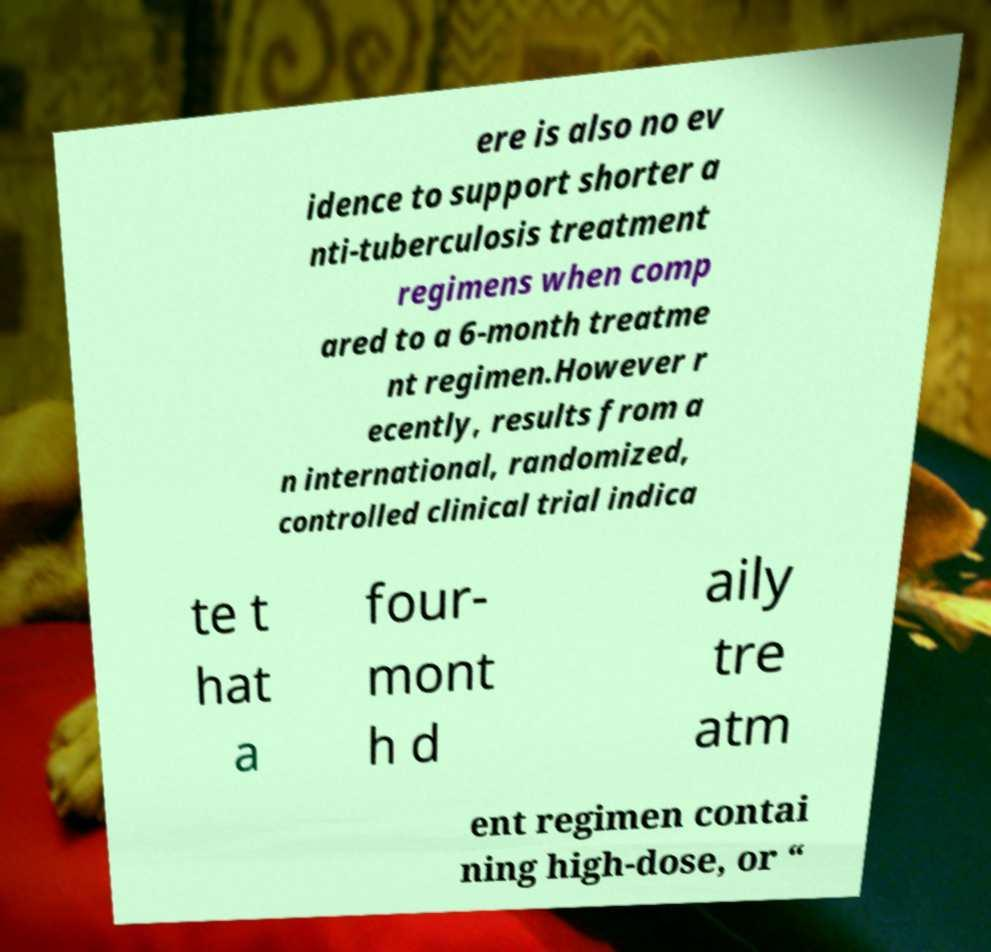Could you extract and type out the text from this image? ere is also no ev idence to support shorter a nti-tuberculosis treatment regimens when comp ared to a 6-month treatme nt regimen.However r ecently, results from a n international, randomized, controlled clinical trial indica te t hat a four- mont h d aily tre atm ent regimen contai ning high-dose, or “ 